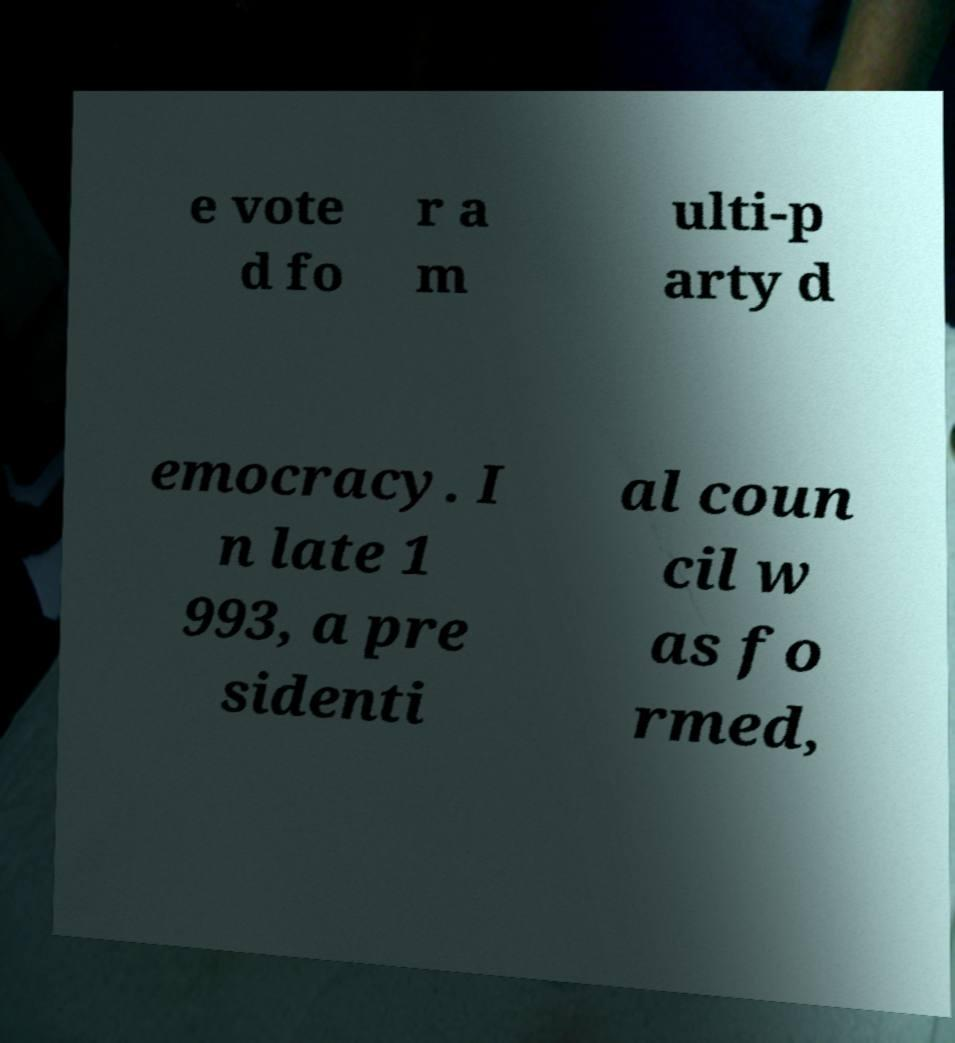Please read and relay the text visible in this image. What does it say? e vote d fo r a m ulti-p arty d emocracy. I n late 1 993, a pre sidenti al coun cil w as fo rmed, 